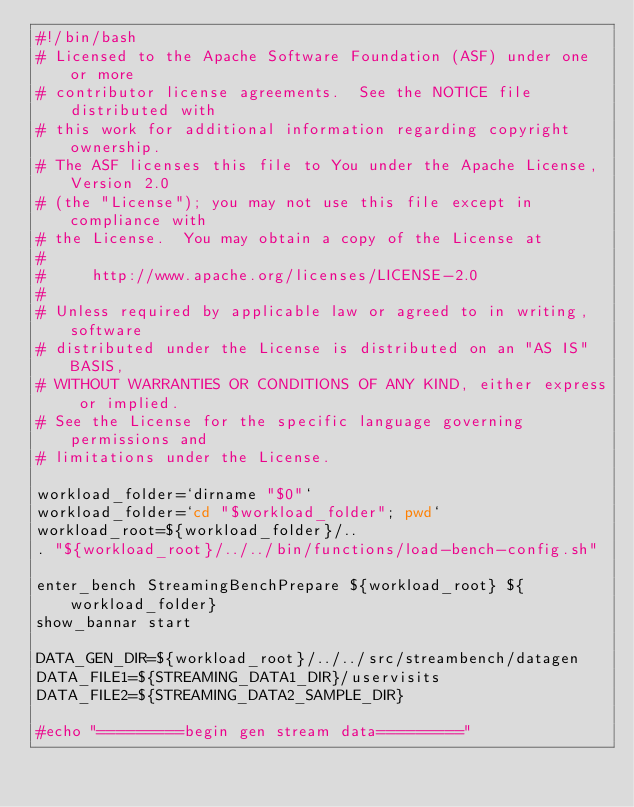<code> <loc_0><loc_0><loc_500><loc_500><_Bash_>#!/bin/bash
# Licensed to the Apache Software Foundation (ASF) under one or more
# contributor license agreements.  See the NOTICE file distributed with
# this work for additional information regarding copyright ownership.
# The ASF licenses this file to You under the Apache License, Version 2.0
# (the "License"); you may not use this file except in compliance with
# the License.  You may obtain a copy of the License at
#
#     http://www.apache.org/licenses/LICENSE-2.0
#
# Unless required by applicable law or agreed to in writing, software
# distributed under the License is distributed on an "AS IS" BASIS,
# WITHOUT WARRANTIES OR CONDITIONS OF ANY KIND, either express or implied.
# See the License for the specific language governing permissions and
# limitations under the License.

workload_folder=`dirname "$0"`
workload_folder=`cd "$workload_folder"; pwd`
workload_root=${workload_folder}/..
. "${workload_root}/../../bin/functions/load-bench-config.sh"

enter_bench StreamingBenchPrepare ${workload_root} ${workload_folder}
show_bannar start

DATA_GEN_DIR=${workload_root}/../../src/streambench/datagen
DATA_FILE1=${STREAMING_DATA1_DIR}/uservisits
DATA_FILE2=${STREAMING_DATA2_SAMPLE_DIR}

#echo "=========begin gen stream data========="</code> 